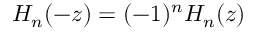Convert formula to latex. <formula><loc_0><loc_0><loc_500><loc_500>H _ { n } ( - z ) = ( - 1 ) ^ { n } H _ { n } ( z )</formula> 